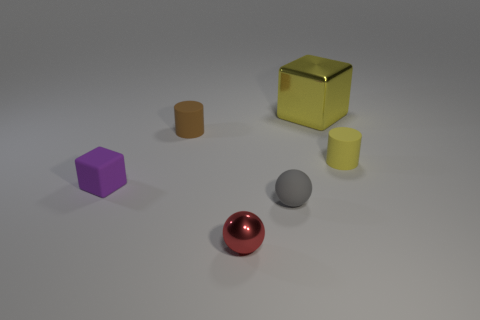The yellow matte object is what shape?
Your answer should be very brief. Cylinder. What number of tiny metal things are the same shape as the big shiny object?
Your answer should be compact. 0. Is the number of tiny brown rubber objects on the left side of the small matte block less than the number of small gray rubber things that are right of the gray rubber object?
Give a very brief answer. No. How many objects are on the left side of the small matte cylinder left of the yellow cube?
Keep it short and to the point. 1. Are there any big purple cubes?
Your answer should be very brief. No. Is there another blue block that has the same material as the large block?
Make the answer very short. No. Is the number of tiny shiny spheres in front of the gray rubber object greater than the number of small red objects that are behind the small metallic ball?
Give a very brief answer. Yes. Is the size of the brown cylinder the same as the yellow matte cylinder?
Your answer should be very brief. Yes. The tiny rubber thing that is in front of the cube that is on the left side of the small gray matte ball is what color?
Your answer should be compact. Gray. The small metallic sphere is what color?
Your answer should be very brief. Red. 